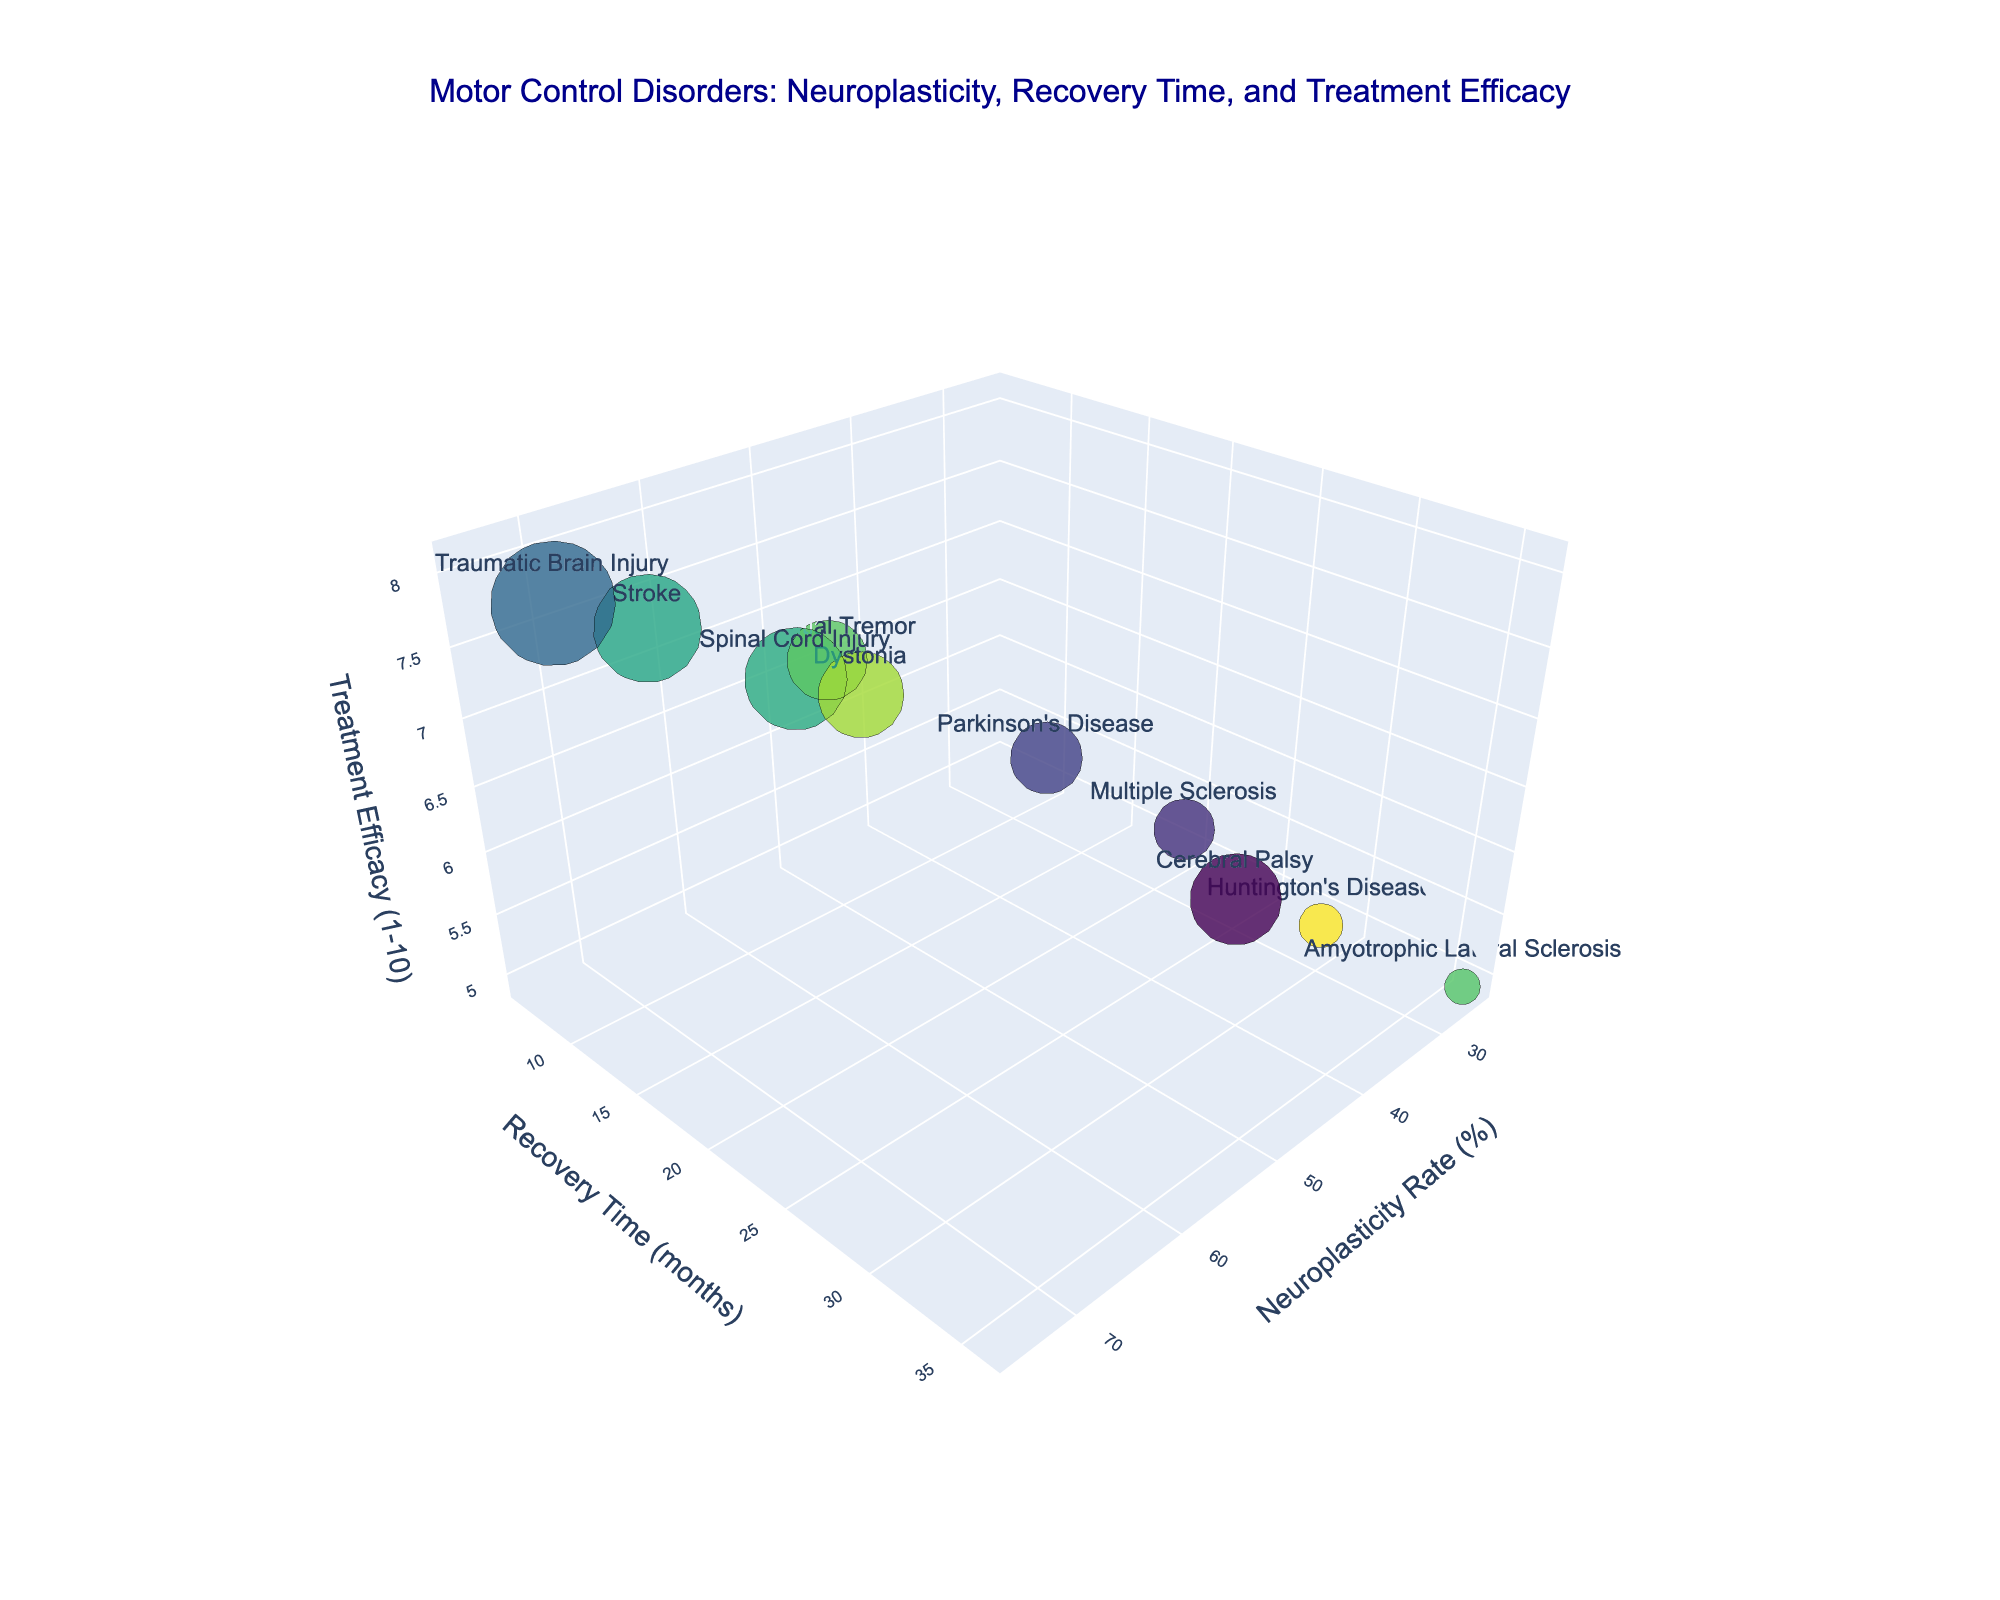What is the title of the figure? The title of the figure is displayed at the top and reads: 'Motor Control Disorders: Neuroplasticity, Recovery Time, and Treatment Efficacy'.
Answer: Motor Control Disorders: Neuroplasticity, Recovery Time, and Treatment Efficacy How many data points are represented in the figure? By counting the bubbles in the figure, we see there are 10 data points, each representing a different motor control disorder.
Answer: 10 Which disorder shows the highest neuroplasticity rate? By locating the bubble positioned furthest to the right on the x-axis, we see that Traumatic Brain Injury has the highest neuroplasticity rate at 75%.
Answer: Traumatic Brain Injury Which disorder has the shortest recovery time? By identifying the bubble positioned lowest on the y-axis, we find that Essential Tremor has the shortest recovery time of 6 months.
Answer: Essential Tremor What is the treatment efficacy for Huntington's Disease, and how does it compare to Amyotrophic Lateral Sclerosis? By examining the hover text for both Huntington's Disease and Amyotrophic Lateral Sclerosis, we see Huntington's Disease has a treatment efficacy of 5.2, while Amyotrophic Lateral Sclerosis has 4.9, meaning Huntington's Disease has a slightly higher efficacy.
Answer: Huntington's Disease: 5.2, Amyotrophic Lateral Sclerosis: 4.9 What is the average neuroplasticity rate among all disorders? Sum the neuroplasticity rates and divide by the number of disorders: (65 + 40 + 75 + 35 + 55 + 60 + 45 + 30 + 50 + 25) / 10 = 480 / 10 = 48%.
Answer: 48% What is the combined recovery time for Parkinson's Disease and Multiple Sclerosis? Add the recovery times for both disorders: 18 months (Parkinson's Disease) + 24 months (Multiple Sclerosis) = 42 months.
Answer: 42 months Which disorder has a neuroplasticity rate less than 40% but a treatment efficacy greater than 6? By examining the figure and hover text, we see Huntington's Disease has a neuroplasticity rate of 30% and a treatment efficacy of 5.2, which doesn't meet the criteria. Instead, there is no disorder that meets both criteria.
Answer: None Which two disorders have the closest treatment efficacy? By comparing treatment efficacy values, Cerebral Palsy (6.9) and Dystonia (6.7) have the closest treatment efficacy.
Answer: Cerebral Palsy and Dystonia 